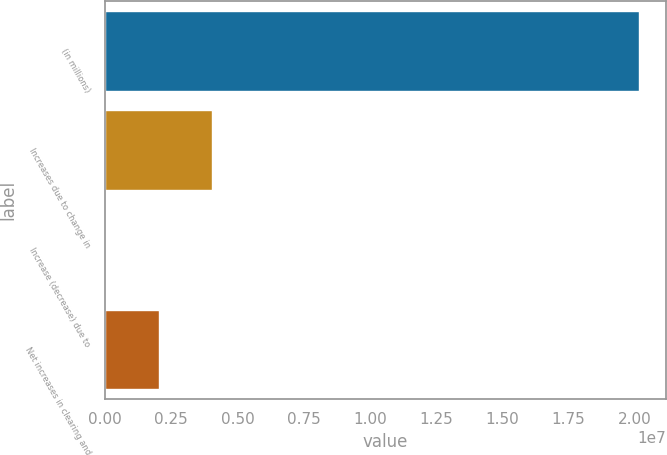<chart> <loc_0><loc_0><loc_500><loc_500><bar_chart><fcel>(in millions)<fcel>Increases due to change in<fcel>Increase (decrease) due to<fcel>Net increases in clearing and<nl><fcel>2.0162e+07<fcel>4.03245e+06<fcel>58.7<fcel>2.01625e+06<nl></chart> 